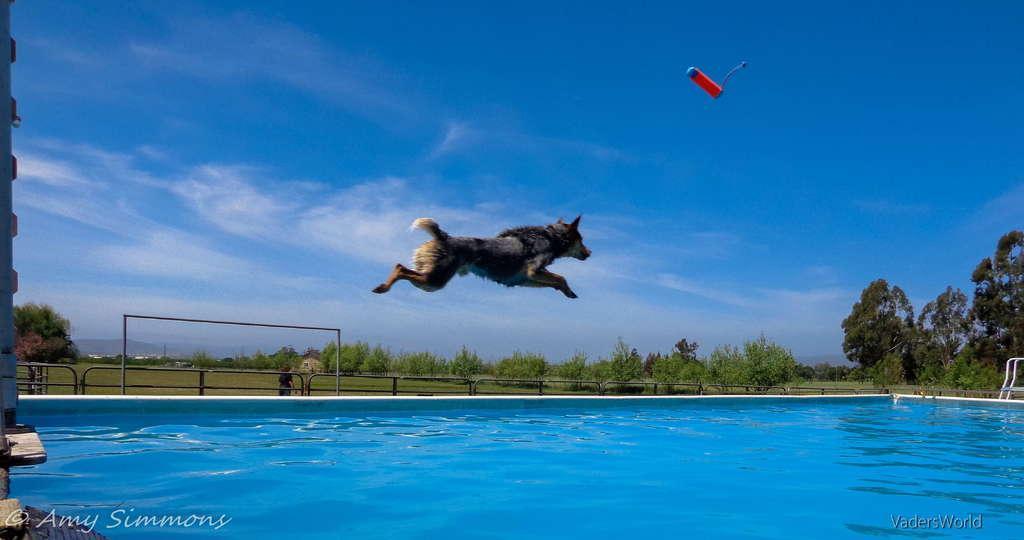Could you give a brief overview of what you see in this image? In this image there is a dog jumping and there is a kind of bottle above the swimming pool, and in the background there are plants, grass, iron rods,a person standing , trees, buildings, hills,sky and there are watermarks on the image. 